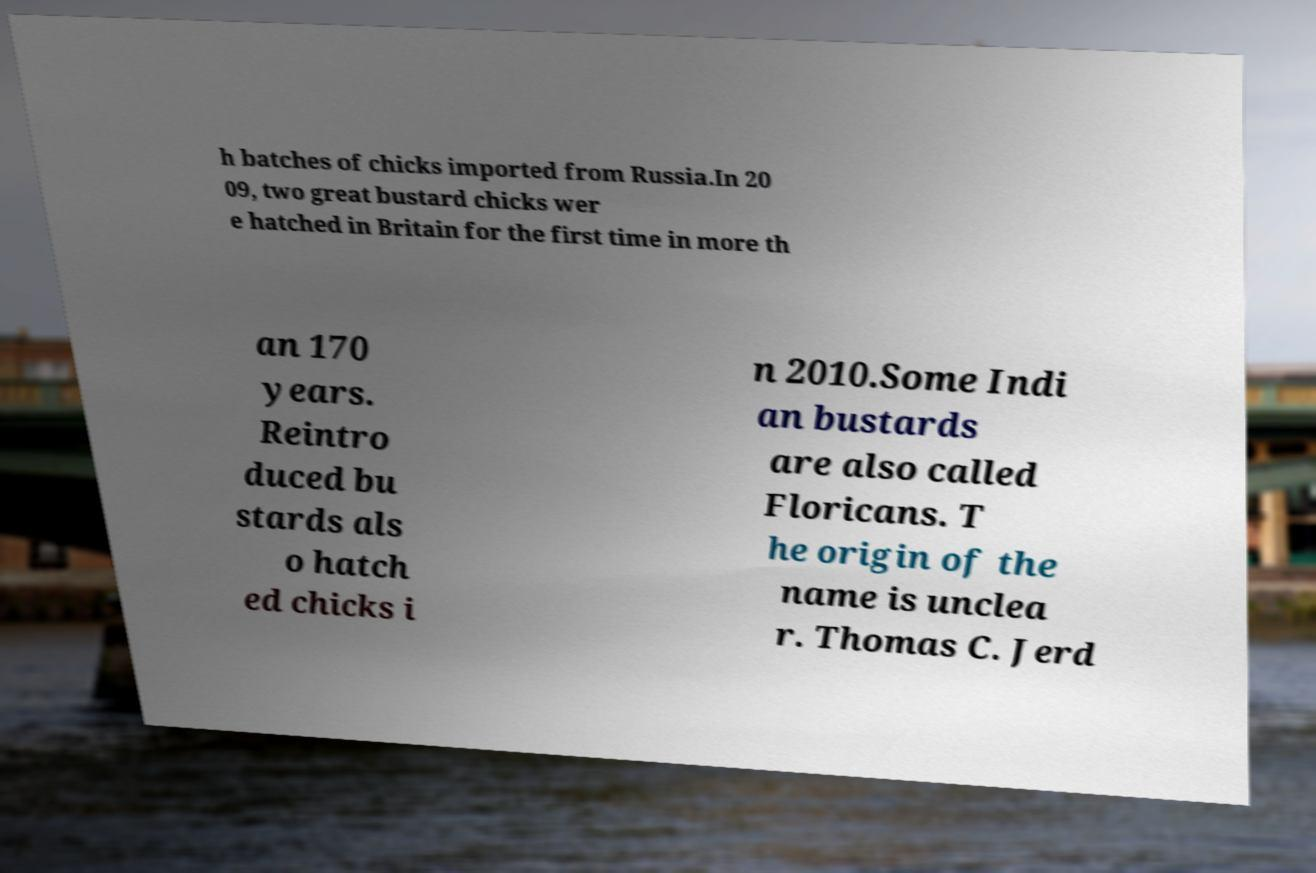There's text embedded in this image that I need extracted. Can you transcribe it verbatim? h batches of chicks imported from Russia.In 20 09, two great bustard chicks wer e hatched in Britain for the first time in more th an 170 years. Reintro duced bu stards als o hatch ed chicks i n 2010.Some Indi an bustards are also called Floricans. T he origin of the name is unclea r. Thomas C. Jerd 